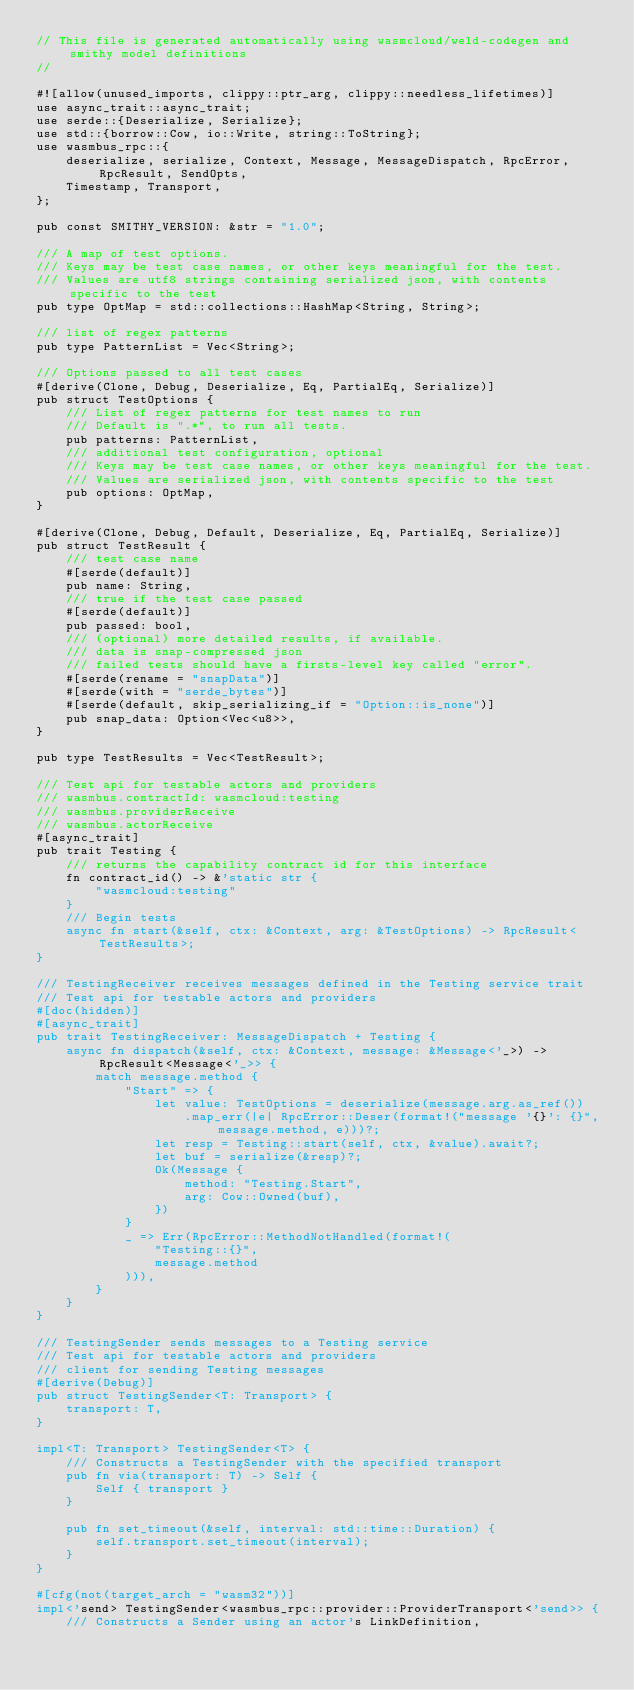<code> <loc_0><loc_0><loc_500><loc_500><_Rust_>// This file is generated automatically using wasmcloud/weld-codegen and smithy model definitions
//

#![allow(unused_imports, clippy::ptr_arg, clippy::needless_lifetimes)]
use async_trait::async_trait;
use serde::{Deserialize, Serialize};
use std::{borrow::Cow, io::Write, string::ToString};
use wasmbus_rpc::{
    deserialize, serialize, Context, Message, MessageDispatch, RpcError, RpcResult, SendOpts,
    Timestamp, Transport,
};

pub const SMITHY_VERSION: &str = "1.0";

/// A map of test options.
/// Keys may be test case names, or other keys meaningful for the test.
/// Values are utf8 strings containing serialized json, with contents specific to the test
pub type OptMap = std::collections::HashMap<String, String>;

/// list of regex patterns
pub type PatternList = Vec<String>;

/// Options passed to all test cases
#[derive(Clone, Debug, Deserialize, Eq, PartialEq, Serialize)]
pub struct TestOptions {
    /// List of regex patterns for test names to run
    /// Default is ".*", to run all tests.
    pub patterns: PatternList,
    /// additional test configuration, optional
    /// Keys may be test case names, or other keys meaningful for the test.
    /// Values are serialized json, with contents specific to the test
    pub options: OptMap,
}

#[derive(Clone, Debug, Default, Deserialize, Eq, PartialEq, Serialize)]
pub struct TestResult {
    /// test case name
    #[serde(default)]
    pub name: String,
    /// true if the test case passed
    #[serde(default)]
    pub passed: bool,
    /// (optional) more detailed results, if available.
    /// data is snap-compressed json
    /// failed tests should have a firsts-level key called "error".
    #[serde(rename = "snapData")]
    #[serde(with = "serde_bytes")]
    #[serde(default, skip_serializing_if = "Option::is_none")]
    pub snap_data: Option<Vec<u8>>,
}

pub type TestResults = Vec<TestResult>;

/// Test api for testable actors and providers
/// wasmbus.contractId: wasmcloud:testing
/// wasmbus.providerReceive
/// wasmbus.actorReceive
#[async_trait]
pub trait Testing {
    /// returns the capability contract id for this interface
    fn contract_id() -> &'static str {
        "wasmcloud:testing"
    }
    /// Begin tests
    async fn start(&self, ctx: &Context, arg: &TestOptions) -> RpcResult<TestResults>;
}

/// TestingReceiver receives messages defined in the Testing service trait
/// Test api for testable actors and providers
#[doc(hidden)]
#[async_trait]
pub trait TestingReceiver: MessageDispatch + Testing {
    async fn dispatch(&self, ctx: &Context, message: &Message<'_>) -> RpcResult<Message<'_>> {
        match message.method {
            "Start" => {
                let value: TestOptions = deserialize(message.arg.as_ref())
                    .map_err(|e| RpcError::Deser(format!("message '{}': {}", message.method, e)))?;
                let resp = Testing::start(self, ctx, &value).await?;
                let buf = serialize(&resp)?;
                Ok(Message {
                    method: "Testing.Start",
                    arg: Cow::Owned(buf),
                })
            }
            _ => Err(RpcError::MethodNotHandled(format!(
                "Testing::{}",
                message.method
            ))),
        }
    }
}

/// TestingSender sends messages to a Testing service
/// Test api for testable actors and providers
/// client for sending Testing messages
#[derive(Debug)]
pub struct TestingSender<T: Transport> {
    transport: T,
}

impl<T: Transport> TestingSender<T> {
    /// Constructs a TestingSender with the specified transport
    pub fn via(transport: T) -> Self {
        Self { transport }
    }

    pub fn set_timeout(&self, interval: std::time::Duration) {
        self.transport.set_timeout(interval);
    }
}

#[cfg(not(target_arch = "wasm32"))]
impl<'send> TestingSender<wasmbus_rpc::provider::ProviderTransport<'send>> {
    /// Constructs a Sender using an actor's LinkDefinition,</code> 